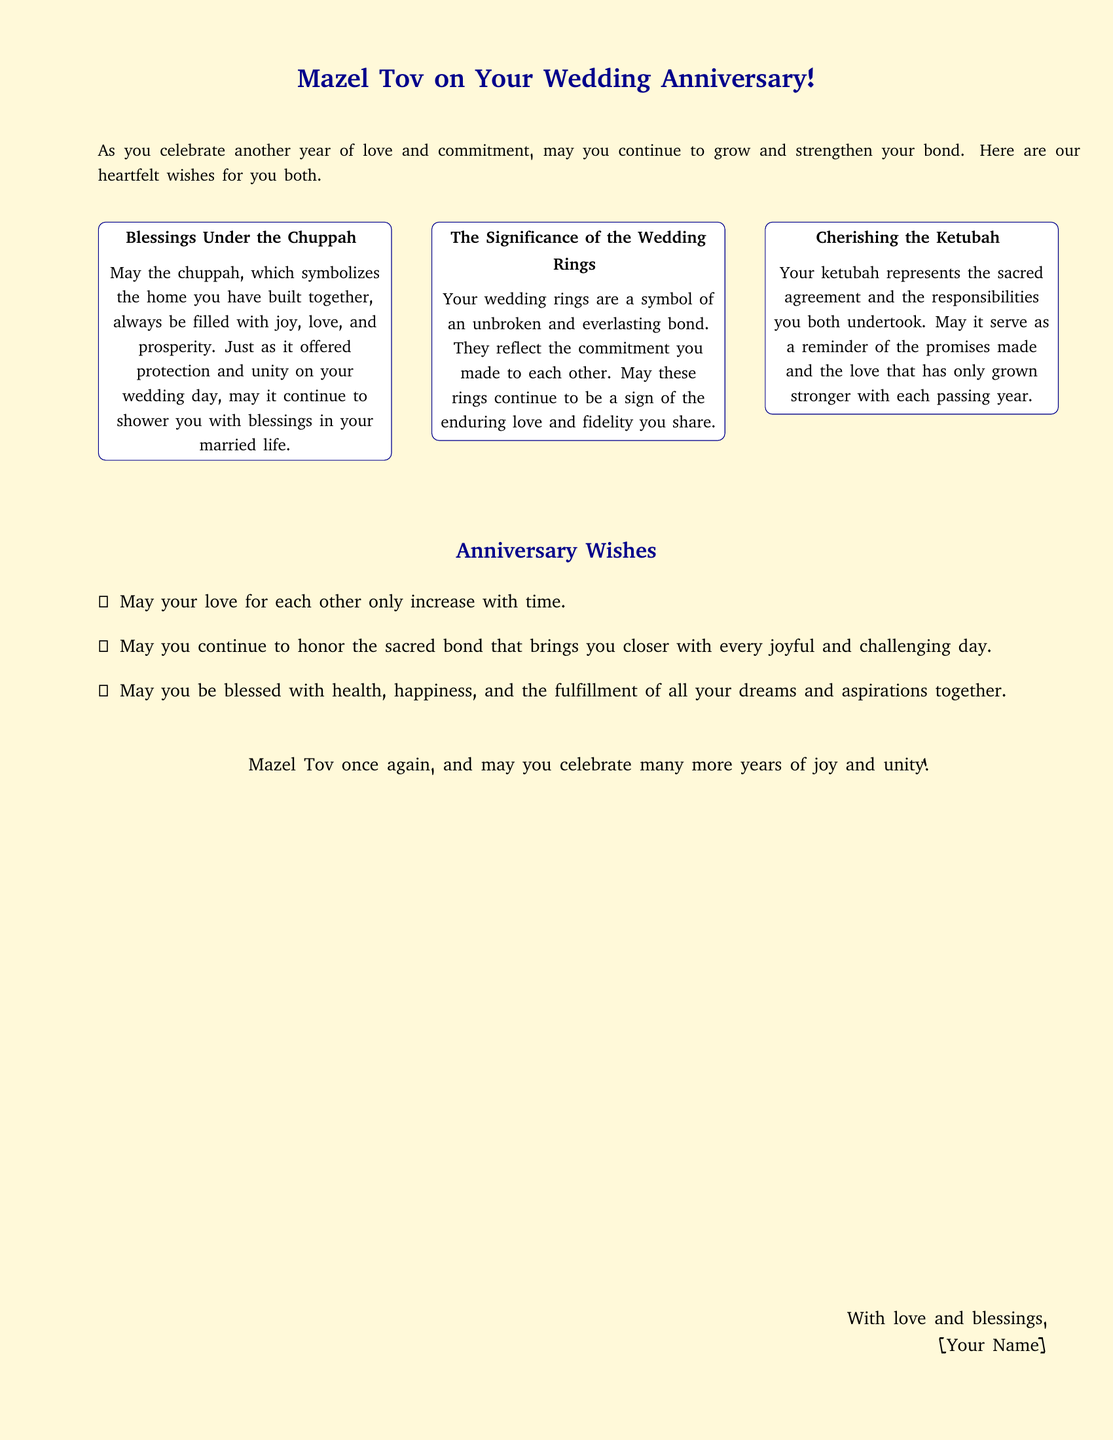What is the main greeting on the card? The main greeting encapsulates the theme of the card, which wishes the couple well on their anniversary.
Answer: Mazel Tov on Your Wedding Anniversary! How many sections are there in the blessings? The card is structured into three distinct sections that provide blessings related to different matrimonial symbols.
Answer: Three What visual symbols are represented in the card? The card references significant symbols related to a Jewish wedding, which are characterized by their importance in matrimonial traditions.
Answer: Chuppah, wedding rings, ketubah What does the ketubah represent in the card? The ketubah is highlighted in the card as a significant element that symbolizes the marital agreement and love.
Answer: Sacred agreement What is included in the anniversary wishes? The wishes in the card encompass hopes for the couple’s love and blessings for their future together.
Answer: Health, happiness, and the fulfillment of all dreams What is the closing remark of the card? The ending of the card provides additional congratulations and reinforces the theme of joy.
Answer: Mazel Tov once again, and may you celebrate many more years of joy and unity! Who is the card sender expected to be? In the concluding section, the card provides a common salutation format for the sender's identification.
Answer: [Your Name] 